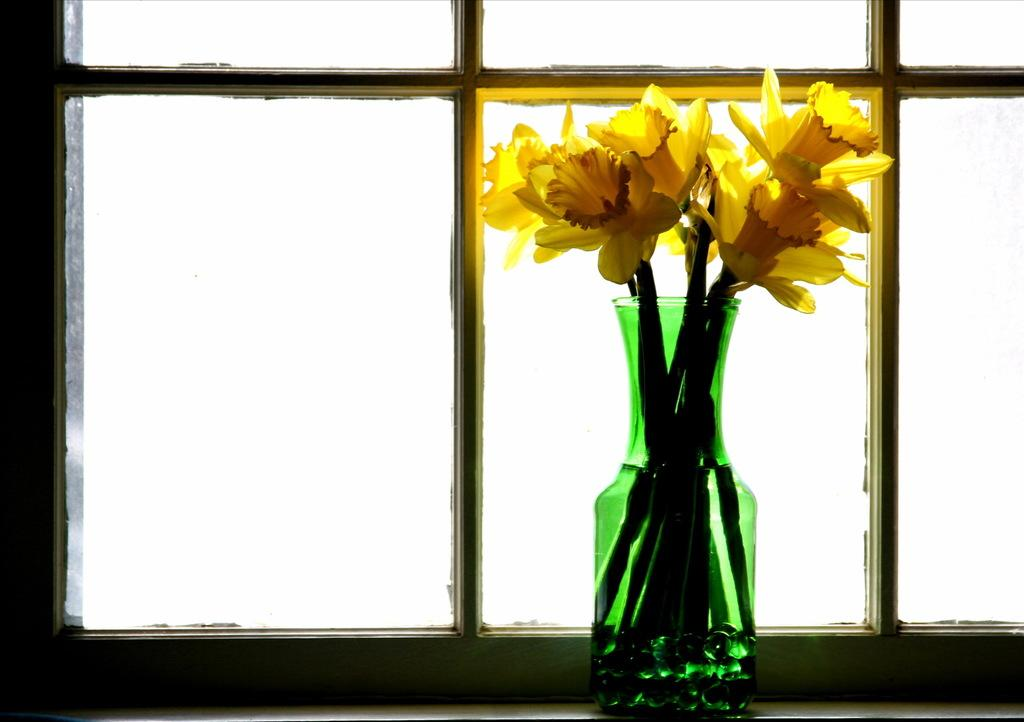What type of objects are in the flower vase? There are flowers in the flower vase. Where is the flower vase located? The flower vase is at the window. What type of education can be seen on the receipt in the image? There is no receipt present in the image, and therefore no education-related information can be observed. 